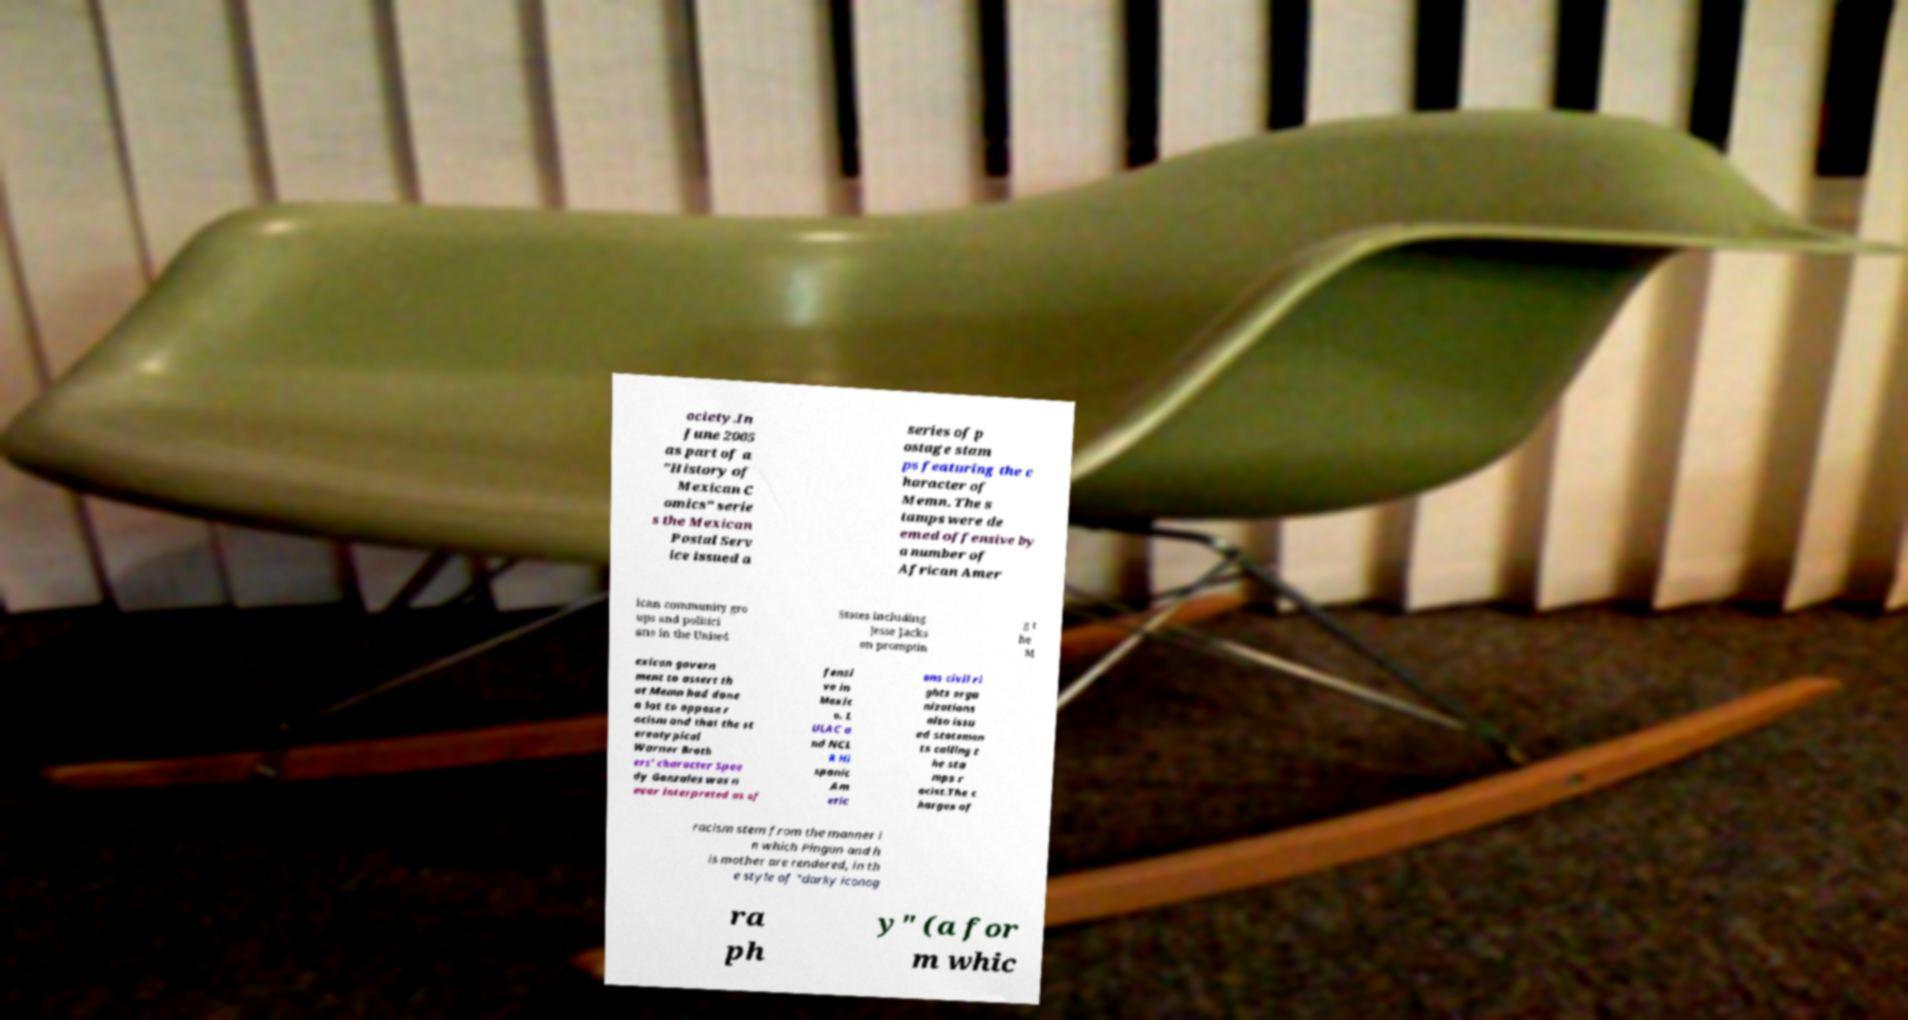Please identify and transcribe the text found in this image. ociety.In June 2005 as part of a "History of Mexican C omics" serie s the Mexican Postal Serv ice issued a series of p ostage stam ps featuring the c haracter of Memn. The s tamps were de emed offensive by a number of African Amer ican community gro ups and politici ans in the United States including Jesse Jacks on promptin g t he M exican govern ment to assert th at Memn had done a lot to oppose r acism and that the st ereotypical Warner Broth ers' character Spee dy Gonzales was n ever interpreted as of fensi ve in Mexic o. L ULAC a nd NCL R Hi spanic Am eric ans civil ri ghts orga nizations also issu ed statemen ts calling t he sta mps r acist.The c harges of racism stem from the manner i n which Pingun and h is mother are rendered, in th e style of "darky iconog ra ph y" (a for m whic 